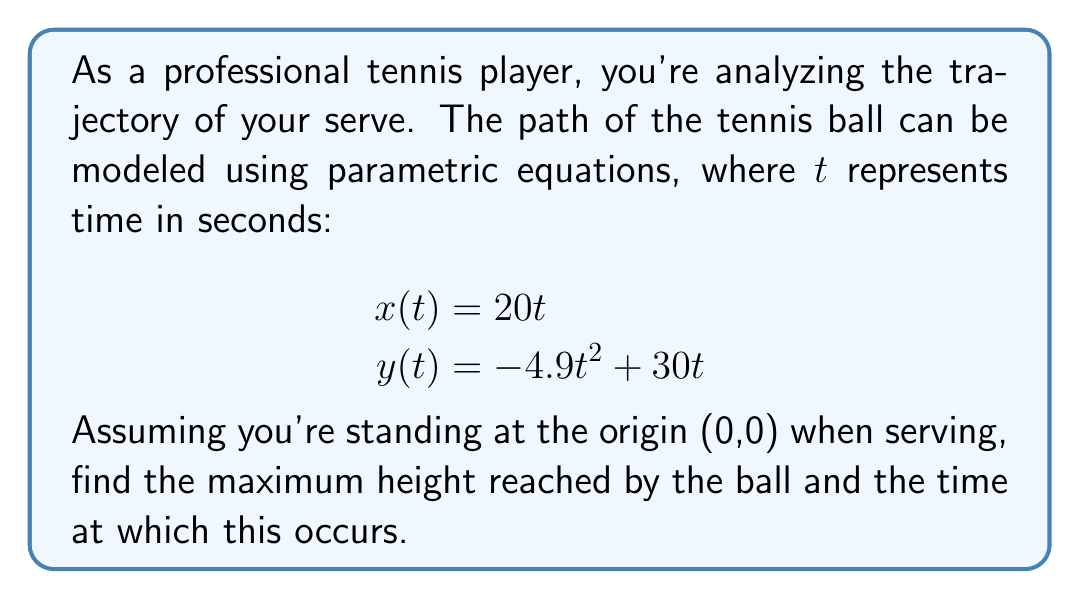Can you solve this math problem? To solve this problem, we'll follow these steps:

1) The maximum height occurs when the y-coordinate reaches its peak. This happens when the vertical velocity (dy/dt) is zero.

2) Find dy/dt by differentiating y(t) with respect to t:
   $$\frac{dy}{dt} = -9.8t + 30$$

3) Set dy/dt = 0 and solve for t:
   $$-9.8t + 30 = 0$$
   $$9.8t = 30$$
   $$t = \frac{30}{9.8} \approx 3.06 \text{ seconds}$$

4) To find the maximum height, substitute this t-value back into the y(t) equation:
   $$y(3.06) = -4.9(3.06)^2 + 30(3.06)$$
   $$= -4.9(9.36) + 91.8$$
   $$= -45.86 + 91.8$$
   $$= 45.94 \text{ meters}$$

Therefore, the ball reaches its maximum height of approximately 45.94 meters after about 3.06 seconds.
Answer: Maximum height: 45.94 meters
Time to reach maximum height: 3.06 seconds 